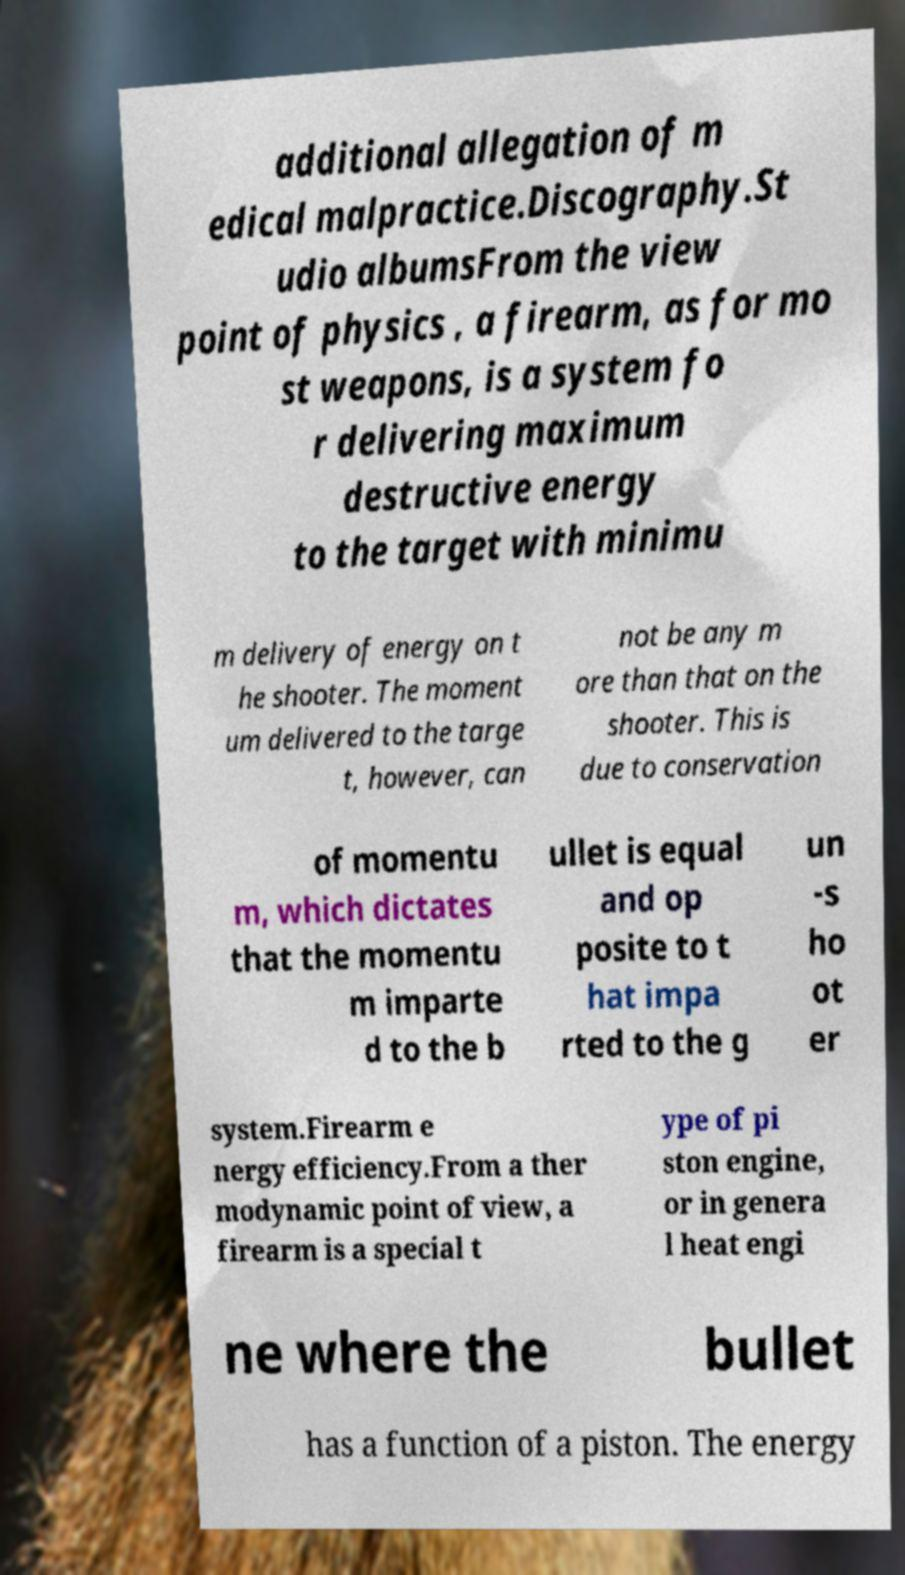What messages or text are displayed in this image? I need them in a readable, typed format. additional allegation of m edical malpractice.Discography.St udio albumsFrom the view point of physics , a firearm, as for mo st weapons, is a system fo r delivering maximum destructive energy to the target with minimu m delivery of energy on t he shooter. The moment um delivered to the targe t, however, can not be any m ore than that on the shooter. This is due to conservation of momentu m, which dictates that the momentu m imparte d to the b ullet is equal and op posite to t hat impa rted to the g un -s ho ot er system.Firearm e nergy efficiency.From a ther modynamic point of view, a firearm is a special t ype of pi ston engine, or in genera l heat engi ne where the bullet has a function of a piston. The energy 